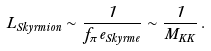<formula> <loc_0><loc_0><loc_500><loc_500>L _ { S k y r m i o n } \sim \frac { 1 } { f _ { \pi } e _ { S k y r m e } } \sim \frac { 1 } { M _ { K K } } \, .</formula> 